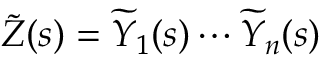<formula> <loc_0><loc_0><loc_500><loc_500>{ \widetilde { Z } } ( s ) = { \widetilde { Y } } _ { 1 } ( s ) \cdots { \widetilde { Y } } _ { n } ( s )</formula> 